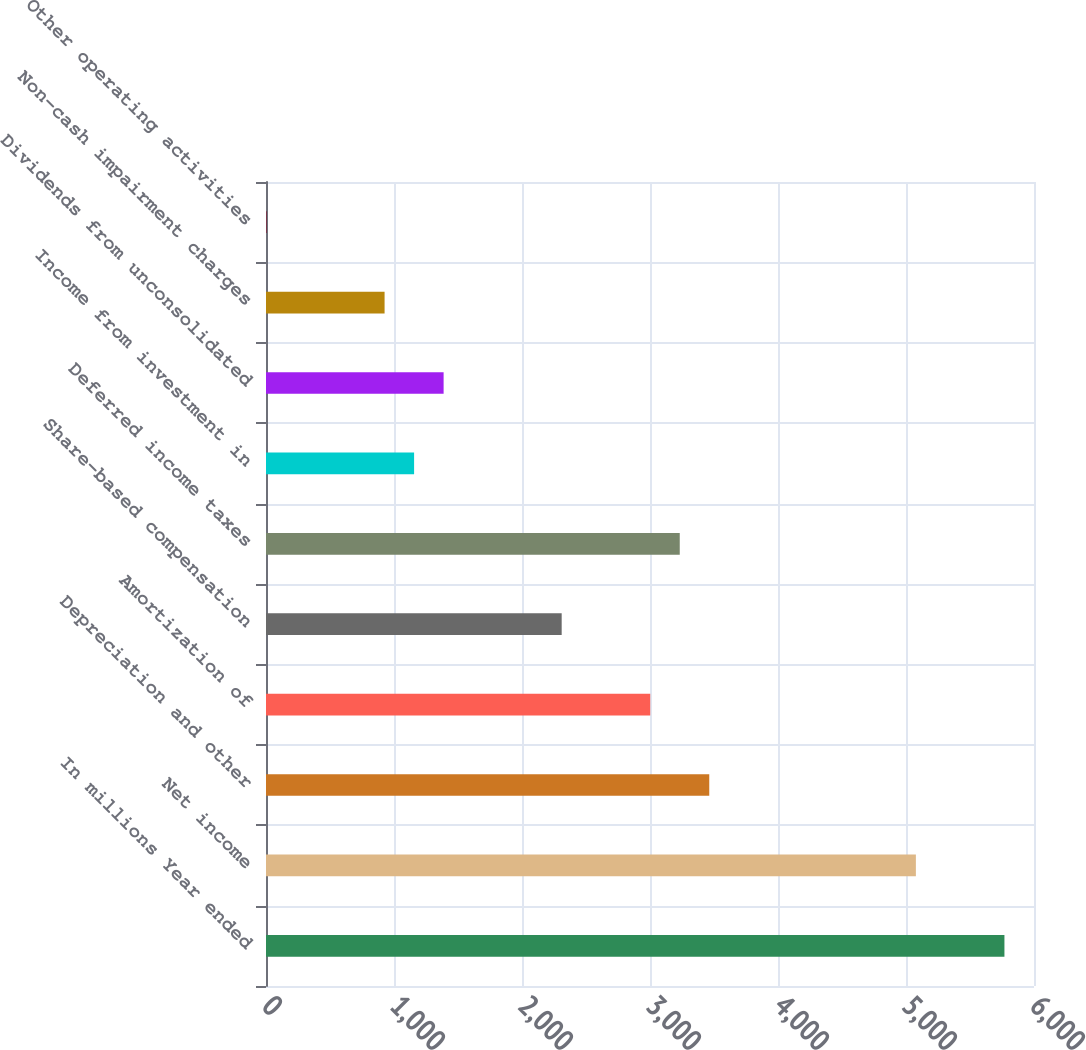<chart> <loc_0><loc_0><loc_500><loc_500><bar_chart><fcel>In millions Year ended<fcel>Net income<fcel>Depreciation and other<fcel>Amortization of<fcel>Share-based compensation<fcel>Deferred income taxes<fcel>Income from investment in<fcel>Dividends from unconsolidated<fcel>Non-cash impairment charges<fcel>Other operating activities<nl><fcel>5769<fcel>5077.2<fcel>3463<fcel>3001.8<fcel>2310<fcel>3232.4<fcel>1157<fcel>1387.6<fcel>926.4<fcel>4<nl></chart> 